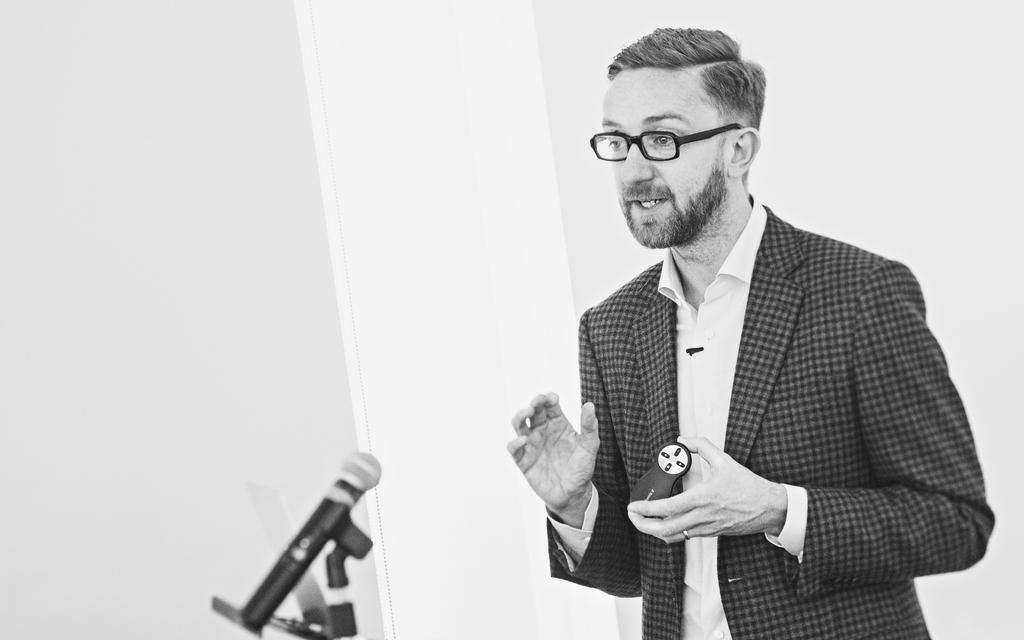What is the man in the image doing? The man is standing in the image. What is the man holding in the image? The man is holding an object. What can be seen in the image besides the man? There is a microphone (mike) in the image. How is the microphone positioned in the image? The microphone is on a stand. What is the color of the background in the image? The background of the image is white. What type of nail does the man have in his hand in the image? There is no nail visible in the man's hand in the image. Is the man a spy in the image? There is no information in the image to suggest that the man is a spy. What is the man's relationship to the person asking the questions in the image? The image does not provide any information about the man's relationship to the person asking the questions. 